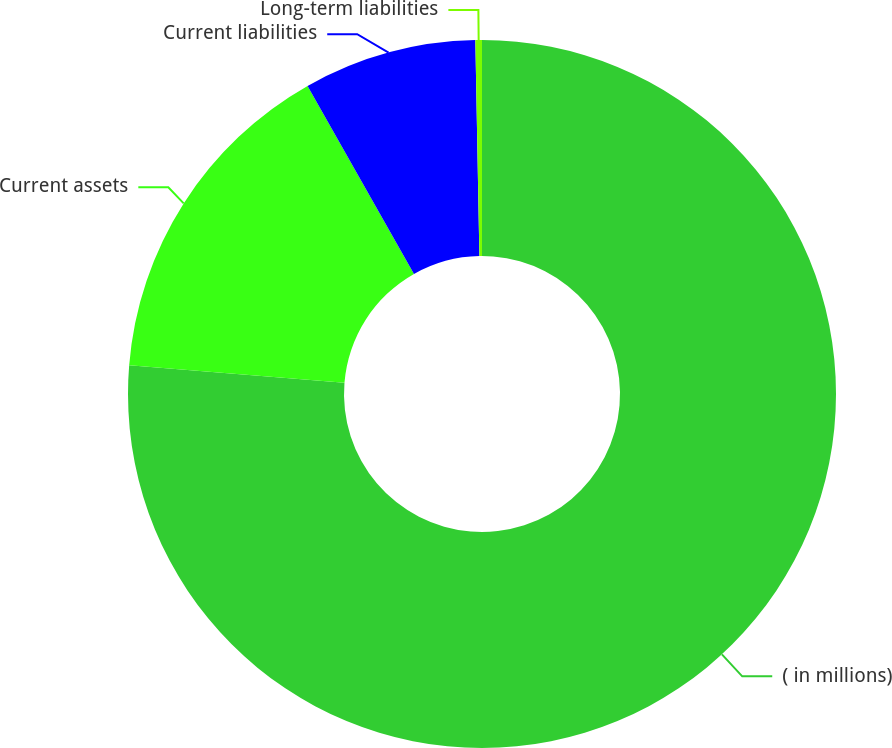Convert chart to OTSL. <chart><loc_0><loc_0><loc_500><loc_500><pie_chart><fcel>( in millions)<fcel>Current assets<fcel>Current liabilities<fcel>Long-term liabilities<nl><fcel>76.29%<fcel>15.5%<fcel>7.9%<fcel>0.3%<nl></chart> 